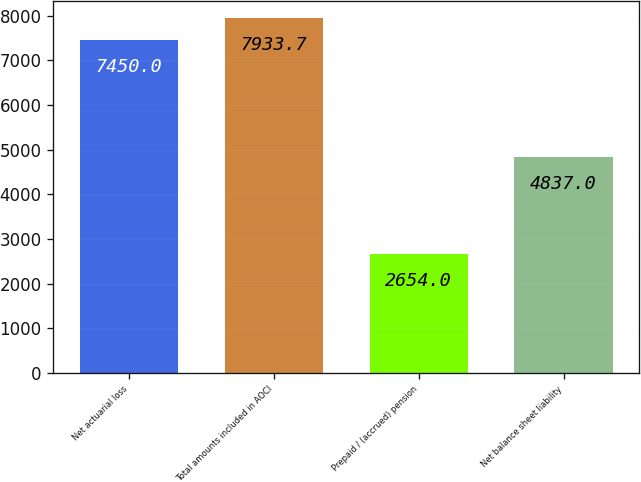Convert chart to OTSL. <chart><loc_0><loc_0><loc_500><loc_500><bar_chart><fcel>Net actuarial loss<fcel>Total amounts included in AOCI<fcel>Prepaid / (accrued) pension<fcel>Net balance sheet liability<nl><fcel>7450<fcel>7933.7<fcel>2654<fcel>4837<nl></chart> 